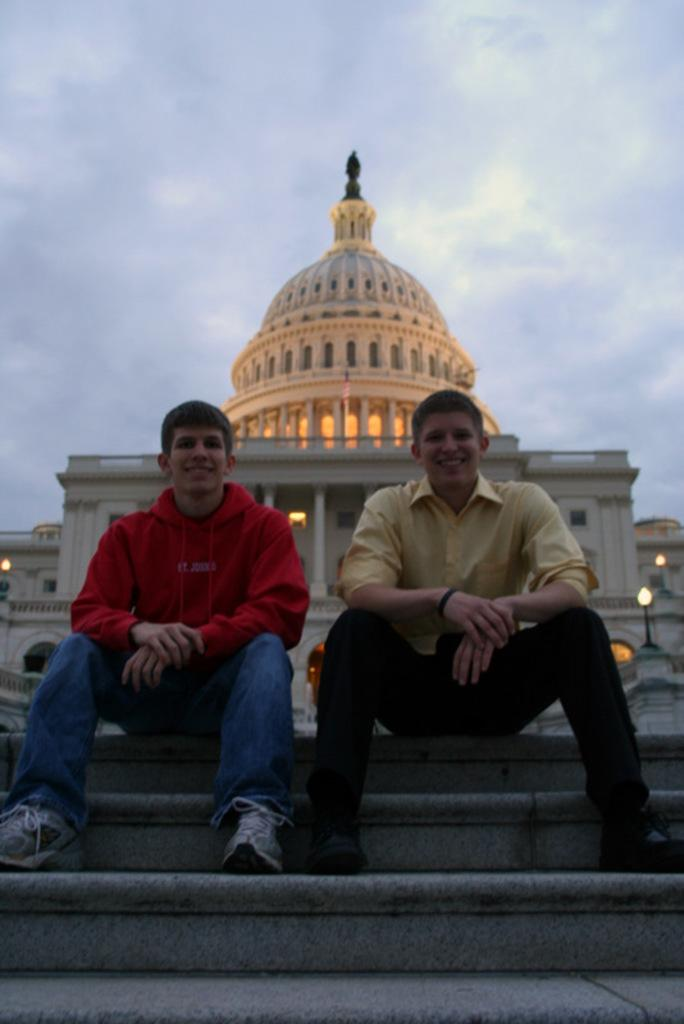What are the two men in the image doing? The two men are sitting on steps in the image. What can be seen in the background behind the men? There is a building with pillars in the background. What type of illumination is present in the image? There are lights visible in the image. What is visible in the sky in the background? The sky is visible with clouds in the background. What political system is being discussed by the two men in the image? There is no indication in the image that the two men are discussing a political system. 